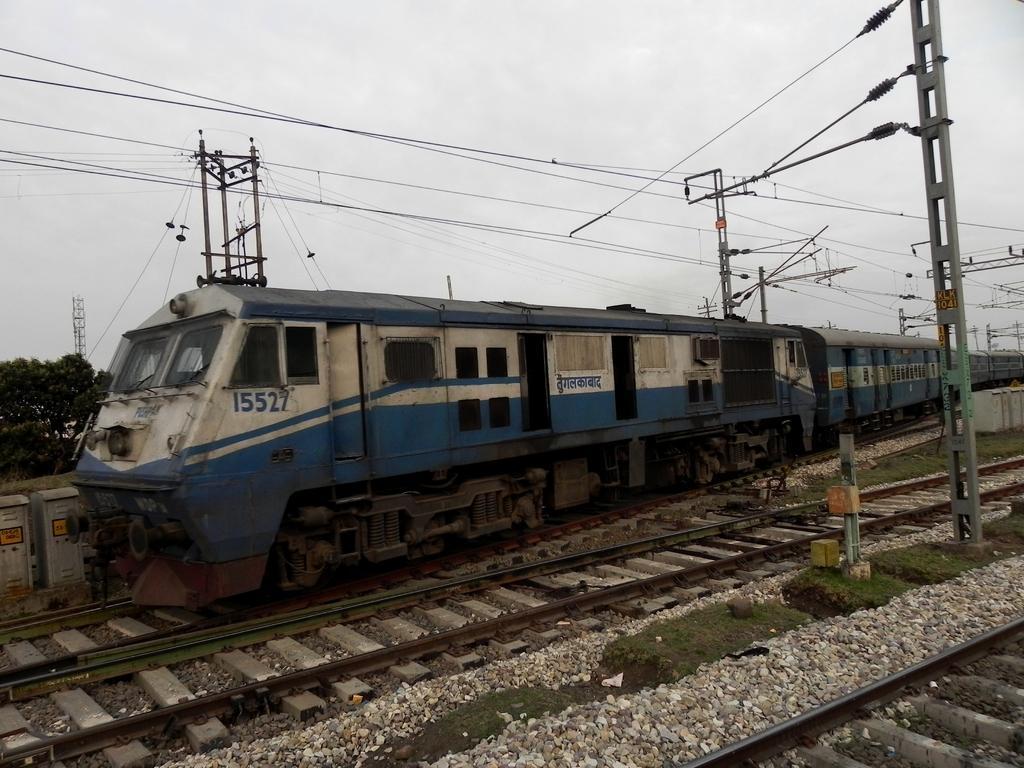In one or two sentences, can you explain what this image depicts? There is a train moving on the railway track, around the train there are many poles attached with plenty of wires and behind the train there are few trees and there are two empty tracks on the other side of the train. 